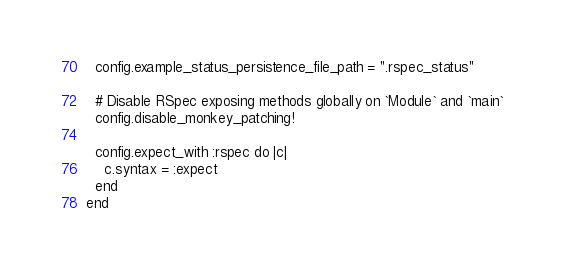Convert code to text. <code><loc_0><loc_0><loc_500><loc_500><_Ruby_>  config.example_status_persistence_file_path = ".rspec_status"

  # Disable RSpec exposing methods globally on `Module` and `main`
  config.disable_monkey_patching!

  config.expect_with :rspec do |c|
    c.syntax = :expect
  end
end
</code> 